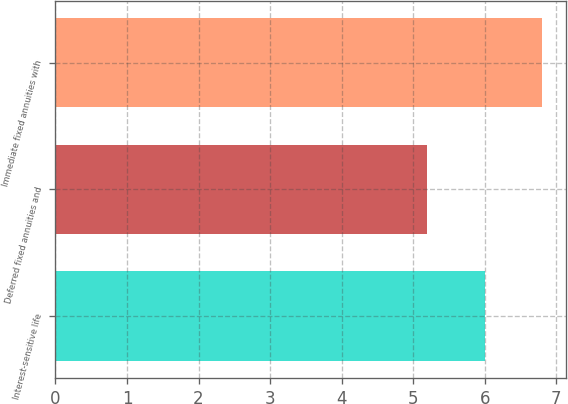Convert chart to OTSL. <chart><loc_0><loc_0><loc_500><loc_500><bar_chart><fcel>Interest-sensitive life<fcel>Deferred fixed annuities and<fcel>Immediate fixed annuities with<nl><fcel>6<fcel>5.2<fcel>6.8<nl></chart> 